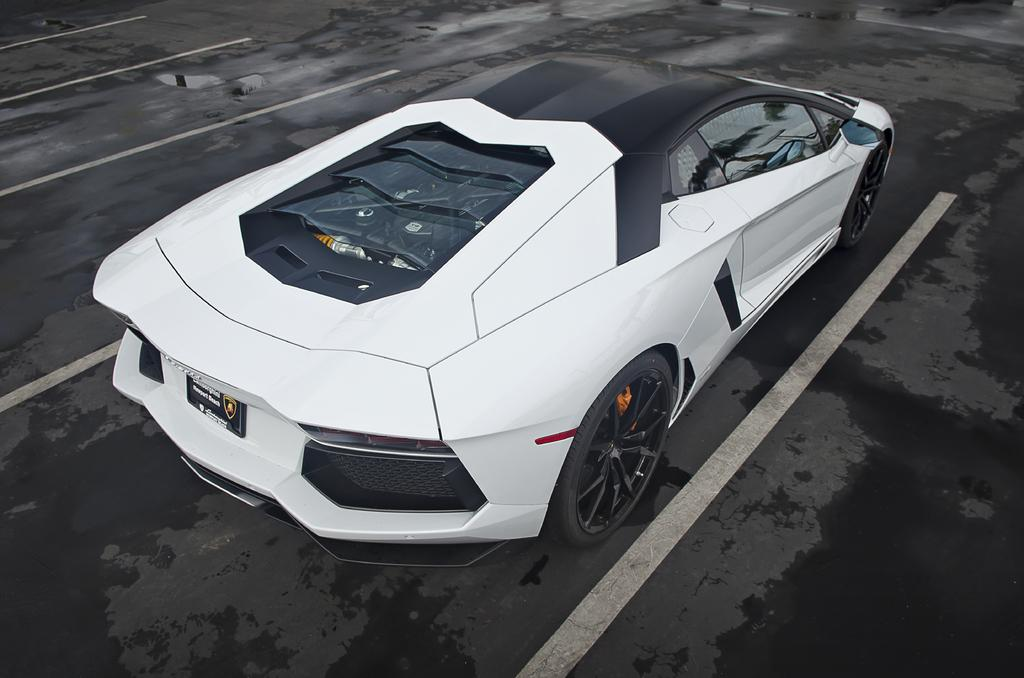What is the main subject of the image? The main subject of the image is a car. Where is the car located in the image? The car is on a roundabout in the image. What color is the car? The car is white in color. In which direction is the car facing? The car is facing towards the right. How many sponges can be seen on the car in the image? There are no sponges present on the car in the image. What type of spark can be seen coming from the car's exhaust in the image? There is no spark coming from the car's exhaust in the image. 